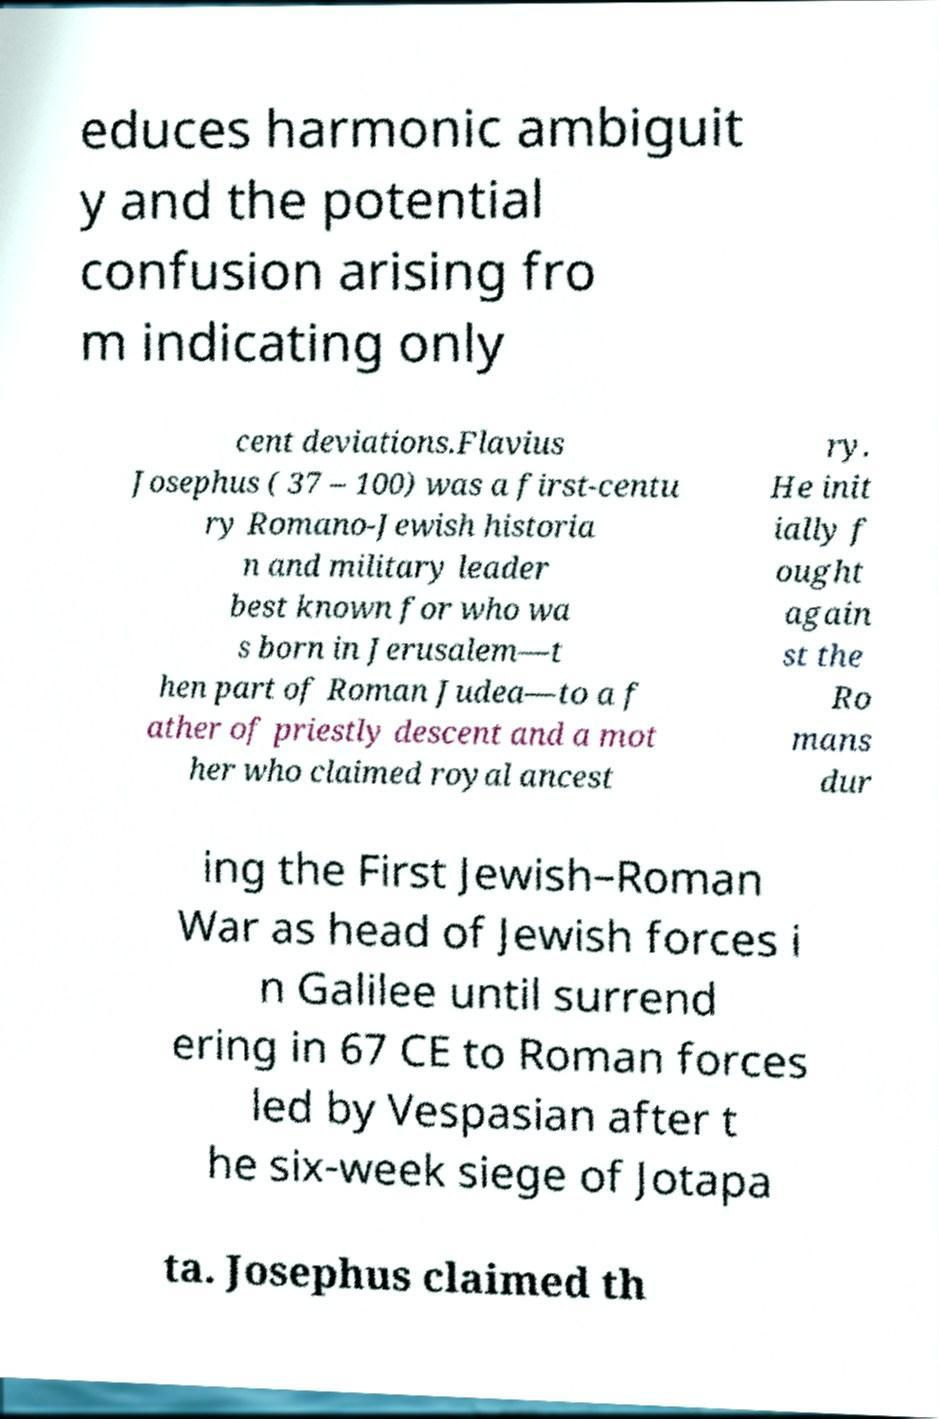There's text embedded in this image that I need extracted. Can you transcribe it verbatim? educes harmonic ambiguit y and the potential confusion arising fro m indicating only cent deviations.Flavius Josephus ( 37 – 100) was a first-centu ry Romano-Jewish historia n and military leader best known for who wa s born in Jerusalem—t hen part of Roman Judea—to a f ather of priestly descent and a mot her who claimed royal ancest ry. He init ially f ought again st the Ro mans dur ing the First Jewish–Roman War as head of Jewish forces i n Galilee until surrend ering in 67 CE to Roman forces led by Vespasian after t he six-week siege of Jotapa ta. Josephus claimed th 